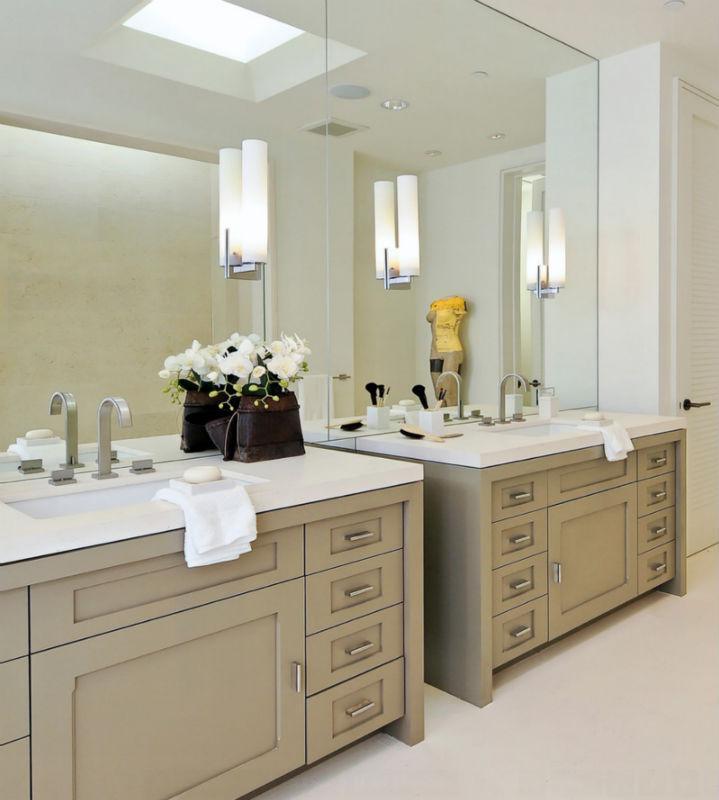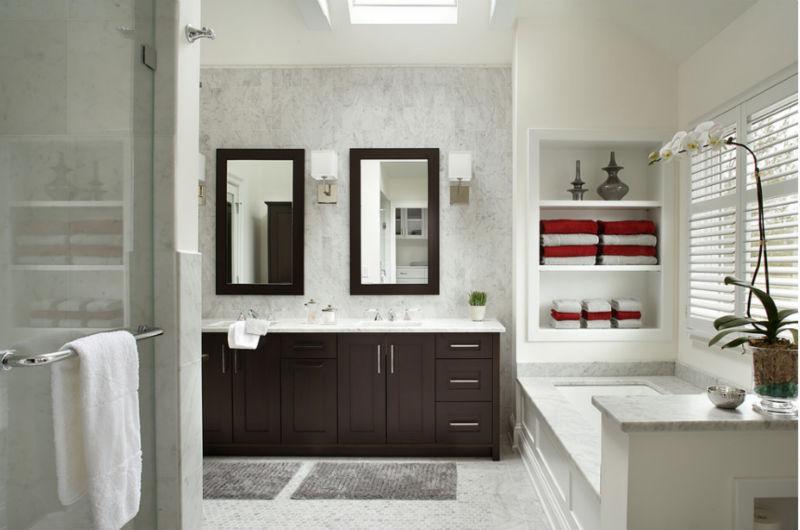The first image is the image on the left, the second image is the image on the right. For the images displayed, is the sentence "Left and right images each show one long counter with two separate sinks displayed at similar angles, and the counter on the right has at least one woven basket under it." factually correct? Answer yes or no. No. The first image is the image on the left, the second image is the image on the right. For the images displayed, is the sentence "In one image two vessel sinks are placed on a vanity with two stacks of white towels on a shelf below." factually correct? Answer yes or no. No. 